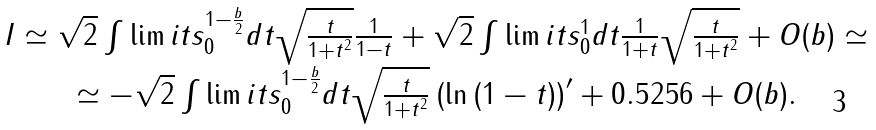Convert formula to latex. <formula><loc_0><loc_0><loc_500><loc_500>\begin{array} { c } I \simeq \sqrt { 2 } \int \lim i t s _ { 0 } ^ { 1 - \frac { b } { 2 } } { d t \sqrt { \frac { t } { 1 + t ^ { 2 } } } \frac { 1 } { 1 - t } } + \sqrt { 2 } \int \lim i t s _ { 0 } ^ { 1 } { d t \frac { 1 } { 1 + t } \sqrt { \frac { t } { 1 + t ^ { 2 } } } } + O ( b ) \simeq \\ \simeq - \sqrt { 2 } \int \lim i t s _ { 0 } ^ { 1 - \frac { b } { 2 } } { d t \sqrt { \frac { t } { 1 + t ^ { 2 } } } \left ( { \ln \left ( { 1 - t } \right ) } \right ) ^ { \prime } } + 0 . 5 2 5 6 + O ( b ) . \\ \end{array}</formula> 